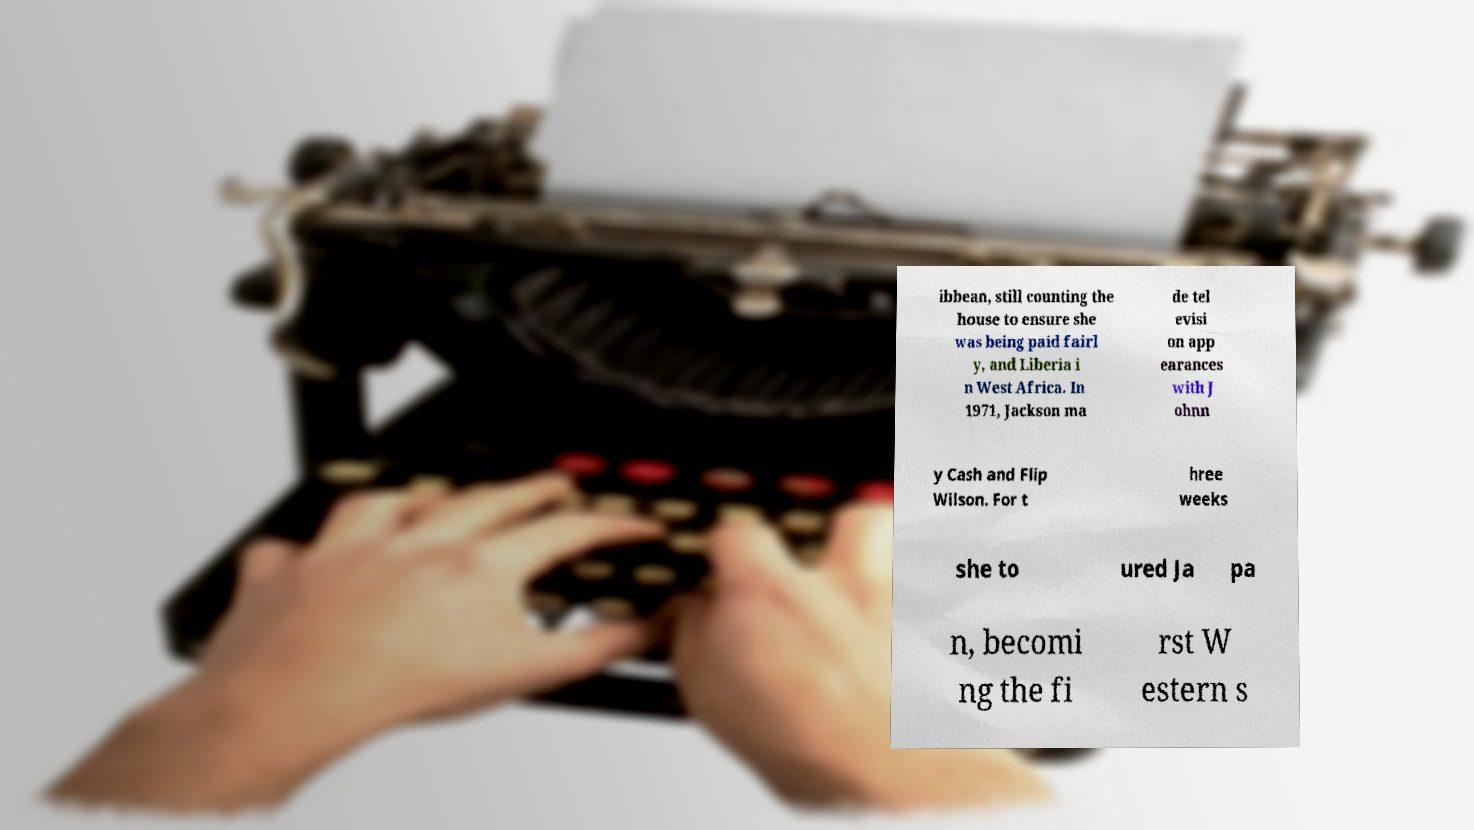Could you extract and type out the text from this image? ibbean, still counting the house to ensure she was being paid fairl y, and Liberia i n West Africa. In 1971, Jackson ma de tel evisi on app earances with J ohnn y Cash and Flip Wilson. For t hree weeks she to ured Ja pa n, becomi ng the fi rst W estern s 